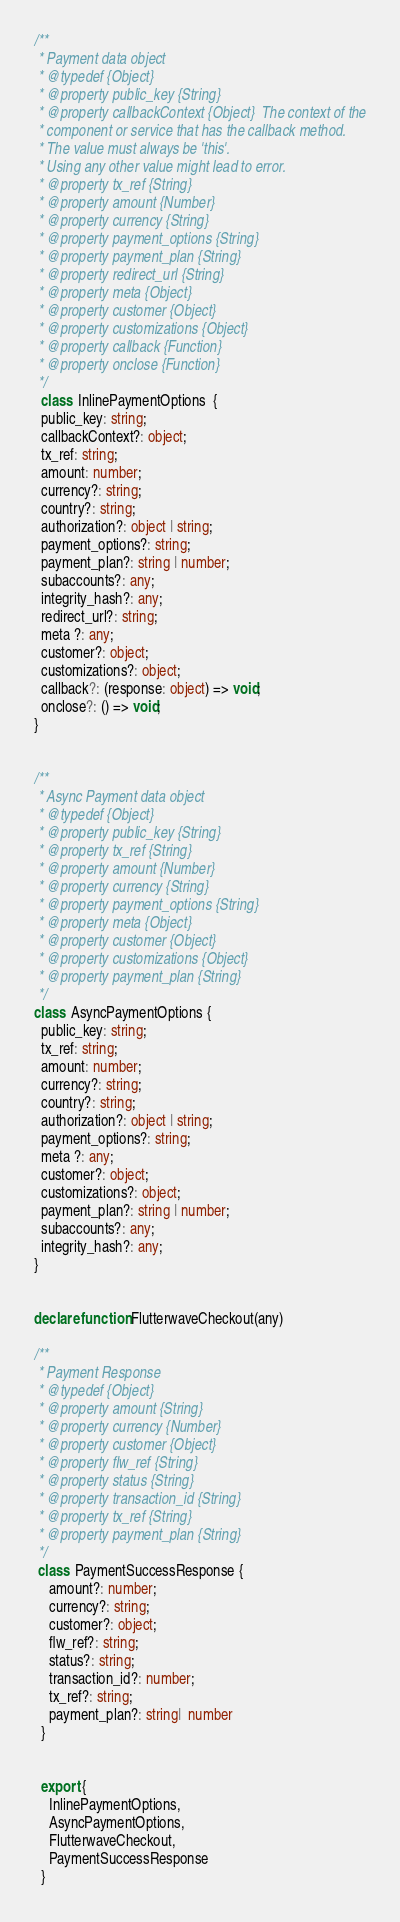<code> <loc_0><loc_0><loc_500><loc_500><_TypeScript_>

/**
 * Payment data object
 * @typedef {Object}
 * @property public_key {String}
 * @property callbackContext {Object}  The context of the
 * component or service that has the callback method.
 * The value must always be 'this'.
 * Using any other value might lead to error.
 * @property tx_ref {String}
 * @property amount {Number}
 * @property currency {String}
 * @property payment_options {String}
 * @property payment_plan {String}
 * @property redirect_url {String}
 * @property meta {Object}
 * @property customer {Object}
 * @property customizations {Object}
 * @property callback {Function}
 * @property onclose {Function}
 */
  class  InlinePaymentOptions  {
  public_key: string;
  callbackContext?: object;
  tx_ref: string;
  amount: number;
  currency?: string;
  country?: string;
  authorization?: object | string;
  payment_options?: string;
  payment_plan?: string | number;
  subaccounts?: any;
  integrity_hash?: any;
  redirect_url?: string;
  meta ?: any;
  customer?: object;
  customizations?: object;
  callback?: (response: object) => void;
  onclose?: () => void;
}


/**
 * Async Payment data object
 * @typedef {Object}
 * @property public_key {String}
 * @property tx_ref {String}
 * @property amount {Number}
 * @property currency {String}
 * @property payment_options {String}
 * @property meta {Object}
 * @property customer {Object}
 * @property customizations {Object}
 * @property payment_plan {String}
 */
class  AsyncPaymentOptions {
  public_key: string;
  tx_ref: string;
  amount: number;
  currency?: string;
  country?: string;
  authorization?: object | string;
  payment_options?: string;
  meta ?: any;
  customer?: object;
  customizations?: object;
  payment_plan?: string | number;
  subaccounts?: any;
  integrity_hash?: any;
}


declare function FlutterwaveCheckout(any)

/**
 * Payment Response
 * @typedef {Object}
 * @property amount {String}
 * @property currency {Number}
 * @property customer {Object}
 * @property flw_ref {String}
 * @property status {String}
 * @property transaction_id {String}
 * @property tx_ref {String}
 * @property payment_plan {String}
 */
 class  PaymentSuccessResponse {
    amount?: number;
    currency?: string;
    customer?: object;
    flw_ref?: string;
    status?: string;
    transaction_id?: number;
    tx_ref?: string;
    payment_plan?: string|  number
  }


  export {
    InlinePaymentOptions,
    AsyncPaymentOptions,
    FlutterwaveCheckout,
    PaymentSuccessResponse
  }
</code> 